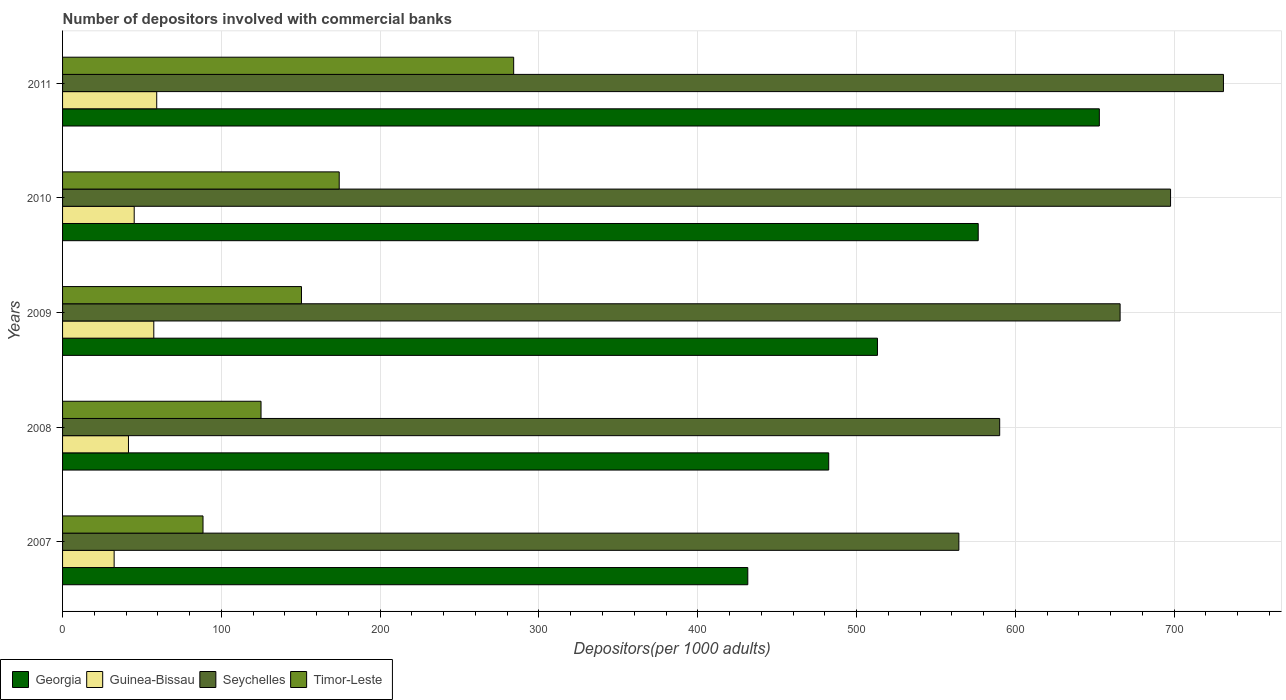How many groups of bars are there?
Make the answer very short. 5. Are the number of bars on each tick of the Y-axis equal?
Ensure brevity in your answer.  Yes. What is the label of the 4th group of bars from the top?
Make the answer very short. 2008. In how many cases, is the number of bars for a given year not equal to the number of legend labels?
Keep it short and to the point. 0. What is the number of depositors involved with commercial banks in Georgia in 2009?
Your answer should be compact. 513.17. Across all years, what is the maximum number of depositors involved with commercial banks in Seychelles?
Your response must be concise. 731.04. Across all years, what is the minimum number of depositors involved with commercial banks in Timor-Leste?
Your answer should be compact. 88.44. In which year was the number of depositors involved with commercial banks in Georgia maximum?
Give a very brief answer. 2011. What is the total number of depositors involved with commercial banks in Timor-Leste in the graph?
Offer a terse response. 822.17. What is the difference between the number of depositors involved with commercial banks in Timor-Leste in 2009 and that in 2011?
Your answer should be very brief. -133.62. What is the difference between the number of depositors involved with commercial banks in Guinea-Bissau in 2009 and the number of depositors involved with commercial banks in Georgia in 2011?
Offer a terse response. -595.44. What is the average number of depositors involved with commercial banks in Georgia per year?
Provide a short and direct response. 531.33. In the year 2011, what is the difference between the number of depositors involved with commercial banks in Georgia and number of depositors involved with commercial banks in Timor-Leste?
Keep it short and to the point. 368.81. In how many years, is the number of depositors involved with commercial banks in Timor-Leste greater than 360 ?
Offer a terse response. 0. What is the ratio of the number of depositors involved with commercial banks in Guinea-Bissau in 2008 to that in 2010?
Your answer should be very brief. 0.92. What is the difference between the highest and the second highest number of depositors involved with commercial banks in Timor-Leste?
Provide a short and direct response. 109.86. What is the difference between the highest and the lowest number of depositors involved with commercial banks in Guinea-Bissau?
Keep it short and to the point. 26.81. Is the sum of the number of depositors involved with commercial banks in Timor-Leste in 2008 and 2011 greater than the maximum number of depositors involved with commercial banks in Georgia across all years?
Keep it short and to the point. No. What does the 4th bar from the top in 2008 represents?
Make the answer very short. Georgia. What does the 4th bar from the bottom in 2007 represents?
Keep it short and to the point. Timor-Leste. Are the values on the major ticks of X-axis written in scientific E-notation?
Your answer should be compact. No. Does the graph contain any zero values?
Keep it short and to the point. No. Does the graph contain grids?
Provide a short and direct response. Yes. What is the title of the graph?
Offer a terse response. Number of depositors involved with commercial banks. What is the label or title of the X-axis?
Your answer should be very brief. Depositors(per 1000 adults). What is the Depositors(per 1000 adults) of Georgia in 2007?
Provide a short and direct response. 431.51. What is the Depositors(per 1000 adults) of Guinea-Bissau in 2007?
Give a very brief answer. 32.48. What is the Depositors(per 1000 adults) in Seychelles in 2007?
Your answer should be very brief. 564.42. What is the Depositors(per 1000 adults) of Timor-Leste in 2007?
Ensure brevity in your answer.  88.44. What is the Depositors(per 1000 adults) of Georgia in 2008?
Offer a very short reply. 482.47. What is the Depositors(per 1000 adults) of Guinea-Bissau in 2008?
Offer a very short reply. 41.5. What is the Depositors(per 1000 adults) in Seychelles in 2008?
Give a very brief answer. 590.13. What is the Depositors(per 1000 adults) of Timor-Leste in 2008?
Your response must be concise. 124.98. What is the Depositors(per 1000 adults) in Georgia in 2009?
Keep it short and to the point. 513.17. What is the Depositors(per 1000 adults) of Guinea-Bissau in 2009?
Your response must be concise. 57.45. What is the Depositors(per 1000 adults) of Seychelles in 2009?
Make the answer very short. 665.96. What is the Depositors(per 1000 adults) of Timor-Leste in 2009?
Offer a terse response. 150.45. What is the Depositors(per 1000 adults) in Georgia in 2010?
Your answer should be compact. 576.61. What is the Depositors(per 1000 adults) in Guinea-Bissau in 2010?
Keep it short and to the point. 45.11. What is the Depositors(per 1000 adults) of Seychelles in 2010?
Provide a succinct answer. 697.73. What is the Depositors(per 1000 adults) in Timor-Leste in 2010?
Ensure brevity in your answer.  174.21. What is the Depositors(per 1000 adults) of Georgia in 2011?
Your answer should be very brief. 652.89. What is the Depositors(per 1000 adults) of Guinea-Bissau in 2011?
Keep it short and to the point. 59.29. What is the Depositors(per 1000 adults) of Seychelles in 2011?
Ensure brevity in your answer.  731.04. What is the Depositors(per 1000 adults) of Timor-Leste in 2011?
Give a very brief answer. 284.07. Across all years, what is the maximum Depositors(per 1000 adults) of Georgia?
Ensure brevity in your answer.  652.89. Across all years, what is the maximum Depositors(per 1000 adults) of Guinea-Bissau?
Your answer should be compact. 59.29. Across all years, what is the maximum Depositors(per 1000 adults) of Seychelles?
Make the answer very short. 731.04. Across all years, what is the maximum Depositors(per 1000 adults) of Timor-Leste?
Your answer should be very brief. 284.07. Across all years, what is the minimum Depositors(per 1000 adults) in Georgia?
Offer a terse response. 431.51. Across all years, what is the minimum Depositors(per 1000 adults) of Guinea-Bissau?
Provide a short and direct response. 32.48. Across all years, what is the minimum Depositors(per 1000 adults) in Seychelles?
Your answer should be very brief. 564.42. Across all years, what is the minimum Depositors(per 1000 adults) of Timor-Leste?
Provide a succinct answer. 88.44. What is the total Depositors(per 1000 adults) of Georgia in the graph?
Offer a terse response. 2656.64. What is the total Depositors(per 1000 adults) in Guinea-Bissau in the graph?
Give a very brief answer. 235.83. What is the total Depositors(per 1000 adults) in Seychelles in the graph?
Your response must be concise. 3249.28. What is the total Depositors(per 1000 adults) in Timor-Leste in the graph?
Provide a succinct answer. 822.17. What is the difference between the Depositors(per 1000 adults) in Georgia in 2007 and that in 2008?
Give a very brief answer. -50.96. What is the difference between the Depositors(per 1000 adults) of Guinea-Bissau in 2007 and that in 2008?
Ensure brevity in your answer.  -9.02. What is the difference between the Depositors(per 1000 adults) of Seychelles in 2007 and that in 2008?
Ensure brevity in your answer.  -25.7. What is the difference between the Depositors(per 1000 adults) of Timor-Leste in 2007 and that in 2008?
Provide a short and direct response. -36.54. What is the difference between the Depositors(per 1000 adults) of Georgia in 2007 and that in 2009?
Provide a succinct answer. -81.65. What is the difference between the Depositors(per 1000 adults) of Guinea-Bissau in 2007 and that in 2009?
Offer a very short reply. -24.97. What is the difference between the Depositors(per 1000 adults) in Seychelles in 2007 and that in 2009?
Your answer should be compact. -101.53. What is the difference between the Depositors(per 1000 adults) in Timor-Leste in 2007 and that in 2009?
Your answer should be compact. -62.01. What is the difference between the Depositors(per 1000 adults) in Georgia in 2007 and that in 2010?
Your response must be concise. -145.1. What is the difference between the Depositors(per 1000 adults) of Guinea-Bissau in 2007 and that in 2010?
Make the answer very short. -12.63. What is the difference between the Depositors(per 1000 adults) of Seychelles in 2007 and that in 2010?
Your answer should be very brief. -133.31. What is the difference between the Depositors(per 1000 adults) of Timor-Leste in 2007 and that in 2010?
Your answer should be very brief. -85.77. What is the difference between the Depositors(per 1000 adults) of Georgia in 2007 and that in 2011?
Your answer should be compact. -221.37. What is the difference between the Depositors(per 1000 adults) in Guinea-Bissau in 2007 and that in 2011?
Your answer should be compact. -26.81. What is the difference between the Depositors(per 1000 adults) in Seychelles in 2007 and that in 2011?
Your answer should be compact. -166.61. What is the difference between the Depositors(per 1000 adults) in Timor-Leste in 2007 and that in 2011?
Keep it short and to the point. -195.63. What is the difference between the Depositors(per 1000 adults) of Georgia in 2008 and that in 2009?
Give a very brief answer. -30.7. What is the difference between the Depositors(per 1000 adults) in Guinea-Bissau in 2008 and that in 2009?
Give a very brief answer. -15.95. What is the difference between the Depositors(per 1000 adults) in Seychelles in 2008 and that in 2009?
Provide a short and direct response. -75.83. What is the difference between the Depositors(per 1000 adults) in Timor-Leste in 2008 and that in 2009?
Your response must be concise. -25.47. What is the difference between the Depositors(per 1000 adults) in Georgia in 2008 and that in 2010?
Keep it short and to the point. -94.14. What is the difference between the Depositors(per 1000 adults) of Guinea-Bissau in 2008 and that in 2010?
Make the answer very short. -3.61. What is the difference between the Depositors(per 1000 adults) in Seychelles in 2008 and that in 2010?
Offer a terse response. -107.6. What is the difference between the Depositors(per 1000 adults) of Timor-Leste in 2008 and that in 2010?
Your answer should be very brief. -49.23. What is the difference between the Depositors(per 1000 adults) of Georgia in 2008 and that in 2011?
Give a very brief answer. -170.42. What is the difference between the Depositors(per 1000 adults) in Guinea-Bissau in 2008 and that in 2011?
Provide a short and direct response. -17.79. What is the difference between the Depositors(per 1000 adults) in Seychelles in 2008 and that in 2011?
Your answer should be compact. -140.91. What is the difference between the Depositors(per 1000 adults) of Timor-Leste in 2008 and that in 2011?
Ensure brevity in your answer.  -159.09. What is the difference between the Depositors(per 1000 adults) of Georgia in 2009 and that in 2010?
Provide a succinct answer. -63.44. What is the difference between the Depositors(per 1000 adults) of Guinea-Bissau in 2009 and that in 2010?
Make the answer very short. 12.34. What is the difference between the Depositors(per 1000 adults) of Seychelles in 2009 and that in 2010?
Your answer should be very brief. -31.77. What is the difference between the Depositors(per 1000 adults) in Timor-Leste in 2009 and that in 2010?
Provide a short and direct response. -23.76. What is the difference between the Depositors(per 1000 adults) of Georgia in 2009 and that in 2011?
Make the answer very short. -139.72. What is the difference between the Depositors(per 1000 adults) in Guinea-Bissau in 2009 and that in 2011?
Provide a short and direct response. -1.84. What is the difference between the Depositors(per 1000 adults) of Seychelles in 2009 and that in 2011?
Your answer should be compact. -65.08. What is the difference between the Depositors(per 1000 adults) in Timor-Leste in 2009 and that in 2011?
Give a very brief answer. -133.62. What is the difference between the Depositors(per 1000 adults) in Georgia in 2010 and that in 2011?
Offer a very short reply. -76.28. What is the difference between the Depositors(per 1000 adults) of Guinea-Bissau in 2010 and that in 2011?
Offer a very short reply. -14.18. What is the difference between the Depositors(per 1000 adults) of Seychelles in 2010 and that in 2011?
Offer a terse response. -33.31. What is the difference between the Depositors(per 1000 adults) in Timor-Leste in 2010 and that in 2011?
Provide a short and direct response. -109.86. What is the difference between the Depositors(per 1000 adults) of Georgia in 2007 and the Depositors(per 1000 adults) of Guinea-Bissau in 2008?
Offer a terse response. 390.01. What is the difference between the Depositors(per 1000 adults) in Georgia in 2007 and the Depositors(per 1000 adults) in Seychelles in 2008?
Make the answer very short. -158.61. What is the difference between the Depositors(per 1000 adults) of Georgia in 2007 and the Depositors(per 1000 adults) of Timor-Leste in 2008?
Keep it short and to the point. 306.53. What is the difference between the Depositors(per 1000 adults) of Guinea-Bissau in 2007 and the Depositors(per 1000 adults) of Seychelles in 2008?
Your response must be concise. -557.64. What is the difference between the Depositors(per 1000 adults) of Guinea-Bissau in 2007 and the Depositors(per 1000 adults) of Timor-Leste in 2008?
Ensure brevity in your answer.  -92.5. What is the difference between the Depositors(per 1000 adults) in Seychelles in 2007 and the Depositors(per 1000 adults) in Timor-Leste in 2008?
Offer a very short reply. 439.44. What is the difference between the Depositors(per 1000 adults) in Georgia in 2007 and the Depositors(per 1000 adults) in Guinea-Bissau in 2009?
Offer a terse response. 374.06. What is the difference between the Depositors(per 1000 adults) of Georgia in 2007 and the Depositors(per 1000 adults) of Seychelles in 2009?
Keep it short and to the point. -234.45. What is the difference between the Depositors(per 1000 adults) in Georgia in 2007 and the Depositors(per 1000 adults) in Timor-Leste in 2009?
Offer a terse response. 281.06. What is the difference between the Depositors(per 1000 adults) in Guinea-Bissau in 2007 and the Depositors(per 1000 adults) in Seychelles in 2009?
Keep it short and to the point. -633.48. What is the difference between the Depositors(per 1000 adults) in Guinea-Bissau in 2007 and the Depositors(per 1000 adults) in Timor-Leste in 2009?
Make the answer very short. -117.97. What is the difference between the Depositors(per 1000 adults) of Seychelles in 2007 and the Depositors(per 1000 adults) of Timor-Leste in 2009?
Your response must be concise. 413.97. What is the difference between the Depositors(per 1000 adults) of Georgia in 2007 and the Depositors(per 1000 adults) of Guinea-Bissau in 2010?
Keep it short and to the point. 386.4. What is the difference between the Depositors(per 1000 adults) of Georgia in 2007 and the Depositors(per 1000 adults) of Seychelles in 2010?
Provide a succinct answer. -266.22. What is the difference between the Depositors(per 1000 adults) of Georgia in 2007 and the Depositors(per 1000 adults) of Timor-Leste in 2010?
Your answer should be very brief. 257.3. What is the difference between the Depositors(per 1000 adults) in Guinea-Bissau in 2007 and the Depositors(per 1000 adults) in Seychelles in 2010?
Your answer should be compact. -665.25. What is the difference between the Depositors(per 1000 adults) of Guinea-Bissau in 2007 and the Depositors(per 1000 adults) of Timor-Leste in 2010?
Offer a very short reply. -141.73. What is the difference between the Depositors(per 1000 adults) of Seychelles in 2007 and the Depositors(per 1000 adults) of Timor-Leste in 2010?
Keep it short and to the point. 390.21. What is the difference between the Depositors(per 1000 adults) in Georgia in 2007 and the Depositors(per 1000 adults) in Guinea-Bissau in 2011?
Provide a succinct answer. 372.22. What is the difference between the Depositors(per 1000 adults) in Georgia in 2007 and the Depositors(per 1000 adults) in Seychelles in 2011?
Keep it short and to the point. -299.53. What is the difference between the Depositors(per 1000 adults) in Georgia in 2007 and the Depositors(per 1000 adults) in Timor-Leste in 2011?
Keep it short and to the point. 147.44. What is the difference between the Depositors(per 1000 adults) in Guinea-Bissau in 2007 and the Depositors(per 1000 adults) in Seychelles in 2011?
Make the answer very short. -698.56. What is the difference between the Depositors(per 1000 adults) in Guinea-Bissau in 2007 and the Depositors(per 1000 adults) in Timor-Leste in 2011?
Ensure brevity in your answer.  -251.59. What is the difference between the Depositors(per 1000 adults) in Seychelles in 2007 and the Depositors(per 1000 adults) in Timor-Leste in 2011?
Your answer should be very brief. 280.35. What is the difference between the Depositors(per 1000 adults) of Georgia in 2008 and the Depositors(per 1000 adults) of Guinea-Bissau in 2009?
Keep it short and to the point. 425.02. What is the difference between the Depositors(per 1000 adults) of Georgia in 2008 and the Depositors(per 1000 adults) of Seychelles in 2009?
Offer a very short reply. -183.49. What is the difference between the Depositors(per 1000 adults) of Georgia in 2008 and the Depositors(per 1000 adults) of Timor-Leste in 2009?
Keep it short and to the point. 332.02. What is the difference between the Depositors(per 1000 adults) of Guinea-Bissau in 2008 and the Depositors(per 1000 adults) of Seychelles in 2009?
Keep it short and to the point. -624.46. What is the difference between the Depositors(per 1000 adults) in Guinea-Bissau in 2008 and the Depositors(per 1000 adults) in Timor-Leste in 2009?
Your answer should be very brief. -108.95. What is the difference between the Depositors(per 1000 adults) in Seychelles in 2008 and the Depositors(per 1000 adults) in Timor-Leste in 2009?
Keep it short and to the point. 439.67. What is the difference between the Depositors(per 1000 adults) in Georgia in 2008 and the Depositors(per 1000 adults) in Guinea-Bissau in 2010?
Your answer should be compact. 437.36. What is the difference between the Depositors(per 1000 adults) of Georgia in 2008 and the Depositors(per 1000 adults) of Seychelles in 2010?
Ensure brevity in your answer.  -215.26. What is the difference between the Depositors(per 1000 adults) in Georgia in 2008 and the Depositors(per 1000 adults) in Timor-Leste in 2010?
Your answer should be very brief. 308.26. What is the difference between the Depositors(per 1000 adults) of Guinea-Bissau in 2008 and the Depositors(per 1000 adults) of Seychelles in 2010?
Make the answer very short. -656.23. What is the difference between the Depositors(per 1000 adults) of Guinea-Bissau in 2008 and the Depositors(per 1000 adults) of Timor-Leste in 2010?
Make the answer very short. -132.71. What is the difference between the Depositors(per 1000 adults) of Seychelles in 2008 and the Depositors(per 1000 adults) of Timor-Leste in 2010?
Ensure brevity in your answer.  415.91. What is the difference between the Depositors(per 1000 adults) in Georgia in 2008 and the Depositors(per 1000 adults) in Guinea-Bissau in 2011?
Provide a short and direct response. 423.18. What is the difference between the Depositors(per 1000 adults) in Georgia in 2008 and the Depositors(per 1000 adults) in Seychelles in 2011?
Keep it short and to the point. -248.57. What is the difference between the Depositors(per 1000 adults) in Georgia in 2008 and the Depositors(per 1000 adults) in Timor-Leste in 2011?
Provide a succinct answer. 198.4. What is the difference between the Depositors(per 1000 adults) in Guinea-Bissau in 2008 and the Depositors(per 1000 adults) in Seychelles in 2011?
Keep it short and to the point. -689.54. What is the difference between the Depositors(per 1000 adults) of Guinea-Bissau in 2008 and the Depositors(per 1000 adults) of Timor-Leste in 2011?
Provide a succinct answer. -242.57. What is the difference between the Depositors(per 1000 adults) of Seychelles in 2008 and the Depositors(per 1000 adults) of Timor-Leste in 2011?
Your answer should be very brief. 306.05. What is the difference between the Depositors(per 1000 adults) in Georgia in 2009 and the Depositors(per 1000 adults) in Guinea-Bissau in 2010?
Your answer should be very brief. 468.05. What is the difference between the Depositors(per 1000 adults) of Georgia in 2009 and the Depositors(per 1000 adults) of Seychelles in 2010?
Make the answer very short. -184.57. What is the difference between the Depositors(per 1000 adults) in Georgia in 2009 and the Depositors(per 1000 adults) in Timor-Leste in 2010?
Keep it short and to the point. 338.95. What is the difference between the Depositors(per 1000 adults) in Guinea-Bissau in 2009 and the Depositors(per 1000 adults) in Seychelles in 2010?
Your answer should be very brief. -640.28. What is the difference between the Depositors(per 1000 adults) in Guinea-Bissau in 2009 and the Depositors(per 1000 adults) in Timor-Leste in 2010?
Provide a succinct answer. -116.77. What is the difference between the Depositors(per 1000 adults) in Seychelles in 2009 and the Depositors(per 1000 adults) in Timor-Leste in 2010?
Keep it short and to the point. 491.75. What is the difference between the Depositors(per 1000 adults) in Georgia in 2009 and the Depositors(per 1000 adults) in Guinea-Bissau in 2011?
Your answer should be compact. 453.87. What is the difference between the Depositors(per 1000 adults) of Georgia in 2009 and the Depositors(per 1000 adults) of Seychelles in 2011?
Provide a succinct answer. -217.87. What is the difference between the Depositors(per 1000 adults) of Georgia in 2009 and the Depositors(per 1000 adults) of Timor-Leste in 2011?
Your answer should be compact. 229.09. What is the difference between the Depositors(per 1000 adults) in Guinea-Bissau in 2009 and the Depositors(per 1000 adults) in Seychelles in 2011?
Offer a terse response. -673.59. What is the difference between the Depositors(per 1000 adults) in Guinea-Bissau in 2009 and the Depositors(per 1000 adults) in Timor-Leste in 2011?
Offer a terse response. -226.62. What is the difference between the Depositors(per 1000 adults) of Seychelles in 2009 and the Depositors(per 1000 adults) of Timor-Leste in 2011?
Offer a very short reply. 381.89. What is the difference between the Depositors(per 1000 adults) of Georgia in 2010 and the Depositors(per 1000 adults) of Guinea-Bissau in 2011?
Keep it short and to the point. 517.32. What is the difference between the Depositors(per 1000 adults) of Georgia in 2010 and the Depositors(per 1000 adults) of Seychelles in 2011?
Keep it short and to the point. -154.43. What is the difference between the Depositors(per 1000 adults) of Georgia in 2010 and the Depositors(per 1000 adults) of Timor-Leste in 2011?
Make the answer very short. 292.54. What is the difference between the Depositors(per 1000 adults) of Guinea-Bissau in 2010 and the Depositors(per 1000 adults) of Seychelles in 2011?
Your answer should be compact. -685.93. What is the difference between the Depositors(per 1000 adults) in Guinea-Bissau in 2010 and the Depositors(per 1000 adults) in Timor-Leste in 2011?
Provide a short and direct response. -238.96. What is the difference between the Depositors(per 1000 adults) of Seychelles in 2010 and the Depositors(per 1000 adults) of Timor-Leste in 2011?
Keep it short and to the point. 413.66. What is the average Depositors(per 1000 adults) in Georgia per year?
Offer a terse response. 531.33. What is the average Depositors(per 1000 adults) of Guinea-Bissau per year?
Your answer should be compact. 47.17. What is the average Depositors(per 1000 adults) of Seychelles per year?
Give a very brief answer. 649.86. What is the average Depositors(per 1000 adults) of Timor-Leste per year?
Your answer should be very brief. 164.43. In the year 2007, what is the difference between the Depositors(per 1000 adults) of Georgia and Depositors(per 1000 adults) of Guinea-Bissau?
Give a very brief answer. 399.03. In the year 2007, what is the difference between the Depositors(per 1000 adults) in Georgia and Depositors(per 1000 adults) in Seychelles?
Keep it short and to the point. -132.91. In the year 2007, what is the difference between the Depositors(per 1000 adults) in Georgia and Depositors(per 1000 adults) in Timor-Leste?
Make the answer very short. 343.07. In the year 2007, what is the difference between the Depositors(per 1000 adults) in Guinea-Bissau and Depositors(per 1000 adults) in Seychelles?
Make the answer very short. -531.94. In the year 2007, what is the difference between the Depositors(per 1000 adults) of Guinea-Bissau and Depositors(per 1000 adults) of Timor-Leste?
Provide a short and direct response. -55.96. In the year 2007, what is the difference between the Depositors(per 1000 adults) in Seychelles and Depositors(per 1000 adults) in Timor-Leste?
Your answer should be compact. 475.98. In the year 2008, what is the difference between the Depositors(per 1000 adults) in Georgia and Depositors(per 1000 adults) in Guinea-Bissau?
Ensure brevity in your answer.  440.97. In the year 2008, what is the difference between the Depositors(per 1000 adults) in Georgia and Depositors(per 1000 adults) in Seychelles?
Provide a short and direct response. -107.66. In the year 2008, what is the difference between the Depositors(per 1000 adults) in Georgia and Depositors(per 1000 adults) in Timor-Leste?
Give a very brief answer. 357.49. In the year 2008, what is the difference between the Depositors(per 1000 adults) in Guinea-Bissau and Depositors(per 1000 adults) in Seychelles?
Your response must be concise. -548.62. In the year 2008, what is the difference between the Depositors(per 1000 adults) in Guinea-Bissau and Depositors(per 1000 adults) in Timor-Leste?
Make the answer very short. -83.48. In the year 2008, what is the difference between the Depositors(per 1000 adults) of Seychelles and Depositors(per 1000 adults) of Timor-Leste?
Offer a terse response. 465.14. In the year 2009, what is the difference between the Depositors(per 1000 adults) in Georgia and Depositors(per 1000 adults) in Guinea-Bissau?
Give a very brief answer. 455.72. In the year 2009, what is the difference between the Depositors(per 1000 adults) of Georgia and Depositors(per 1000 adults) of Seychelles?
Give a very brief answer. -152.79. In the year 2009, what is the difference between the Depositors(per 1000 adults) in Georgia and Depositors(per 1000 adults) in Timor-Leste?
Ensure brevity in your answer.  362.71. In the year 2009, what is the difference between the Depositors(per 1000 adults) of Guinea-Bissau and Depositors(per 1000 adults) of Seychelles?
Provide a short and direct response. -608.51. In the year 2009, what is the difference between the Depositors(per 1000 adults) of Guinea-Bissau and Depositors(per 1000 adults) of Timor-Leste?
Give a very brief answer. -93. In the year 2009, what is the difference between the Depositors(per 1000 adults) of Seychelles and Depositors(per 1000 adults) of Timor-Leste?
Provide a succinct answer. 515.51. In the year 2010, what is the difference between the Depositors(per 1000 adults) of Georgia and Depositors(per 1000 adults) of Guinea-Bissau?
Give a very brief answer. 531.5. In the year 2010, what is the difference between the Depositors(per 1000 adults) in Georgia and Depositors(per 1000 adults) in Seychelles?
Your answer should be very brief. -121.12. In the year 2010, what is the difference between the Depositors(per 1000 adults) of Georgia and Depositors(per 1000 adults) of Timor-Leste?
Offer a terse response. 402.39. In the year 2010, what is the difference between the Depositors(per 1000 adults) of Guinea-Bissau and Depositors(per 1000 adults) of Seychelles?
Ensure brevity in your answer.  -652.62. In the year 2010, what is the difference between the Depositors(per 1000 adults) in Guinea-Bissau and Depositors(per 1000 adults) in Timor-Leste?
Ensure brevity in your answer.  -129.1. In the year 2010, what is the difference between the Depositors(per 1000 adults) of Seychelles and Depositors(per 1000 adults) of Timor-Leste?
Make the answer very short. 523.52. In the year 2011, what is the difference between the Depositors(per 1000 adults) of Georgia and Depositors(per 1000 adults) of Guinea-Bissau?
Give a very brief answer. 593.6. In the year 2011, what is the difference between the Depositors(per 1000 adults) of Georgia and Depositors(per 1000 adults) of Seychelles?
Make the answer very short. -78.15. In the year 2011, what is the difference between the Depositors(per 1000 adults) of Georgia and Depositors(per 1000 adults) of Timor-Leste?
Your answer should be very brief. 368.81. In the year 2011, what is the difference between the Depositors(per 1000 adults) in Guinea-Bissau and Depositors(per 1000 adults) in Seychelles?
Keep it short and to the point. -671.75. In the year 2011, what is the difference between the Depositors(per 1000 adults) of Guinea-Bissau and Depositors(per 1000 adults) of Timor-Leste?
Your answer should be very brief. -224.78. In the year 2011, what is the difference between the Depositors(per 1000 adults) in Seychelles and Depositors(per 1000 adults) in Timor-Leste?
Provide a short and direct response. 446.97. What is the ratio of the Depositors(per 1000 adults) in Georgia in 2007 to that in 2008?
Make the answer very short. 0.89. What is the ratio of the Depositors(per 1000 adults) in Guinea-Bissau in 2007 to that in 2008?
Your answer should be very brief. 0.78. What is the ratio of the Depositors(per 1000 adults) in Seychelles in 2007 to that in 2008?
Your answer should be compact. 0.96. What is the ratio of the Depositors(per 1000 adults) in Timor-Leste in 2007 to that in 2008?
Keep it short and to the point. 0.71. What is the ratio of the Depositors(per 1000 adults) in Georgia in 2007 to that in 2009?
Provide a short and direct response. 0.84. What is the ratio of the Depositors(per 1000 adults) in Guinea-Bissau in 2007 to that in 2009?
Your response must be concise. 0.57. What is the ratio of the Depositors(per 1000 adults) of Seychelles in 2007 to that in 2009?
Provide a succinct answer. 0.85. What is the ratio of the Depositors(per 1000 adults) of Timor-Leste in 2007 to that in 2009?
Your answer should be compact. 0.59. What is the ratio of the Depositors(per 1000 adults) of Georgia in 2007 to that in 2010?
Provide a short and direct response. 0.75. What is the ratio of the Depositors(per 1000 adults) in Guinea-Bissau in 2007 to that in 2010?
Provide a short and direct response. 0.72. What is the ratio of the Depositors(per 1000 adults) of Seychelles in 2007 to that in 2010?
Give a very brief answer. 0.81. What is the ratio of the Depositors(per 1000 adults) in Timor-Leste in 2007 to that in 2010?
Offer a terse response. 0.51. What is the ratio of the Depositors(per 1000 adults) in Georgia in 2007 to that in 2011?
Give a very brief answer. 0.66. What is the ratio of the Depositors(per 1000 adults) in Guinea-Bissau in 2007 to that in 2011?
Offer a very short reply. 0.55. What is the ratio of the Depositors(per 1000 adults) in Seychelles in 2007 to that in 2011?
Your response must be concise. 0.77. What is the ratio of the Depositors(per 1000 adults) in Timor-Leste in 2007 to that in 2011?
Your answer should be compact. 0.31. What is the ratio of the Depositors(per 1000 adults) of Georgia in 2008 to that in 2009?
Offer a terse response. 0.94. What is the ratio of the Depositors(per 1000 adults) in Guinea-Bissau in 2008 to that in 2009?
Give a very brief answer. 0.72. What is the ratio of the Depositors(per 1000 adults) of Seychelles in 2008 to that in 2009?
Your answer should be very brief. 0.89. What is the ratio of the Depositors(per 1000 adults) of Timor-Leste in 2008 to that in 2009?
Offer a very short reply. 0.83. What is the ratio of the Depositors(per 1000 adults) of Georgia in 2008 to that in 2010?
Make the answer very short. 0.84. What is the ratio of the Depositors(per 1000 adults) of Seychelles in 2008 to that in 2010?
Provide a succinct answer. 0.85. What is the ratio of the Depositors(per 1000 adults) in Timor-Leste in 2008 to that in 2010?
Make the answer very short. 0.72. What is the ratio of the Depositors(per 1000 adults) in Georgia in 2008 to that in 2011?
Give a very brief answer. 0.74. What is the ratio of the Depositors(per 1000 adults) of Guinea-Bissau in 2008 to that in 2011?
Your response must be concise. 0.7. What is the ratio of the Depositors(per 1000 adults) in Seychelles in 2008 to that in 2011?
Your answer should be very brief. 0.81. What is the ratio of the Depositors(per 1000 adults) in Timor-Leste in 2008 to that in 2011?
Keep it short and to the point. 0.44. What is the ratio of the Depositors(per 1000 adults) in Georgia in 2009 to that in 2010?
Provide a succinct answer. 0.89. What is the ratio of the Depositors(per 1000 adults) in Guinea-Bissau in 2009 to that in 2010?
Your answer should be compact. 1.27. What is the ratio of the Depositors(per 1000 adults) of Seychelles in 2009 to that in 2010?
Keep it short and to the point. 0.95. What is the ratio of the Depositors(per 1000 adults) of Timor-Leste in 2009 to that in 2010?
Provide a succinct answer. 0.86. What is the ratio of the Depositors(per 1000 adults) in Georgia in 2009 to that in 2011?
Give a very brief answer. 0.79. What is the ratio of the Depositors(per 1000 adults) of Guinea-Bissau in 2009 to that in 2011?
Ensure brevity in your answer.  0.97. What is the ratio of the Depositors(per 1000 adults) of Seychelles in 2009 to that in 2011?
Offer a terse response. 0.91. What is the ratio of the Depositors(per 1000 adults) of Timor-Leste in 2009 to that in 2011?
Your answer should be compact. 0.53. What is the ratio of the Depositors(per 1000 adults) in Georgia in 2010 to that in 2011?
Make the answer very short. 0.88. What is the ratio of the Depositors(per 1000 adults) of Guinea-Bissau in 2010 to that in 2011?
Your answer should be compact. 0.76. What is the ratio of the Depositors(per 1000 adults) of Seychelles in 2010 to that in 2011?
Your answer should be very brief. 0.95. What is the ratio of the Depositors(per 1000 adults) of Timor-Leste in 2010 to that in 2011?
Offer a very short reply. 0.61. What is the difference between the highest and the second highest Depositors(per 1000 adults) of Georgia?
Your response must be concise. 76.28. What is the difference between the highest and the second highest Depositors(per 1000 adults) of Guinea-Bissau?
Offer a terse response. 1.84. What is the difference between the highest and the second highest Depositors(per 1000 adults) of Seychelles?
Provide a short and direct response. 33.31. What is the difference between the highest and the second highest Depositors(per 1000 adults) of Timor-Leste?
Your response must be concise. 109.86. What is the difference between the highest and the lowest Depositors(per 1000 adults) of Georgia?
Offer a terse response. 221.37. What is the difference between the highest and the lowest Depositors(per 1000 adults) of Guinea-Bissau?
Offer a very short reply. 26.81. What is the difference between the highest and the lowest Depositors(per 1000 adults) in Seychelles?
Offer a terse response. 166.61. What is the difference between the highest and the lowest Depositors(per 1000 adults) of Timor-Leste?
Provide a succinct answer. 195.63. 